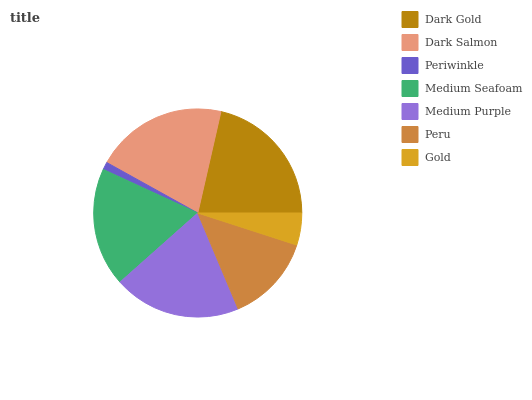Is Periwinkle the minimum?
Answer yes or no. Yes. Is Dark Gold the maximum?
Answer yes or no. Yes. Is Dark Salmon the minimum?
Answer yes or no. No. Is Dark Salmon the maximum?
Answer yes or no. No. Is Dark Gold greater than Dark Salmon?
Answer yes or no. Yes. Is Dark Salmon less than Dark Gold?
Answer yes or no. Yes. Is Dark Salmon greater than Dark Gold?
Answer yes or no. No. Is Dark Gold less than Dark Salmon?
Answer yes or no. No. Is Medium Seafoam the high median?
Answer yes or no. Yes. Is Medium Seafoam the low median?
Answer yes or no. Yes. Is Dark Gold the high median?
Answer yes or no. No. Is Dark Salmon the low median?
Answer yes or no. No. 